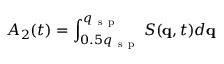Convert formula to latex. <formula><loc_0><loc_0><loc_500><loc_500>A _ { 2 } ( t ) = \int _ { 0 . 5 q _ { s p } } ^ { q _ { s p } } { S ( q , t ) d q }</formula> 